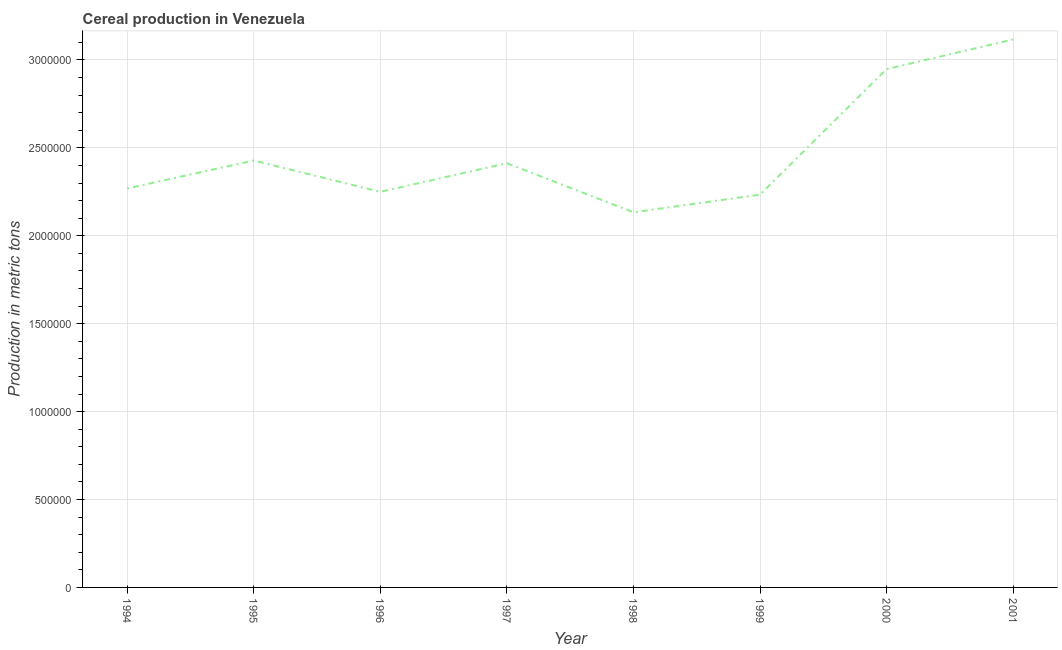What is the cereal production in 1998?
Provide a short and direct response. 2.13e+06. Across all years, what is the maximum cereal production?
Your response must be concise. 3.12e+06. Across all years, what is the minimum cereal production?
Provide a succinct answer. 2.13e+06. In which year was the cereal production maximum?
Offer a very short reply. 2001. What is the sum of the cereal production?
Your answer should be very brief. 1.98e+07. What is the difference between the cereal production in 1999 and 2000?
Provide a succinct answer. -7.14e+05. What is the average cereal production per year?
Your answer should be very brief. 2.47e+06. What is the median cereal production?
Keep it short and to the point. 2.34e+06. In how many years, is the cereal production greater than 800000 metric tons?
Make the answer very short. 8. Do a majority of the years between 1995 and 1996 (inclusive) have cereal production greater than 100000 metric tons?
Your answer should be very brief. Yes. What is the ratio of the cereal production in 1995 to that in 2000?
Provide a succinct answer. 0.82. Is the cereal production in 1995 less than that in 1996?
Keep it short and to the point. No. Is the difference between the cereal production in 1995 and 1998 greater than the difference between any two years?
Offer a very short reply. No. What is the difference between the highest and the second highest cereal production?
Provide a succinct answer. 1.68e+05. Is the sum of the cereal production in 1996 and 2000 greater than the maximum cereal production across all years?
Provide a short and direct response. Yes. What is the difference between the highest and the lowest cereal production?
Offer a terse response. 9.83e+05. In how many years, is the cereal production greater than the average cereal production taken over all years?
Provide a succinct answer. 2. Does the cereal production monotonically increase over the years?
Give a very brief answer. No. How many years are there in the graph?
Ensure brevity in your answer.  8. Are the values on the major ticks of Y-axis written in scientific E-notation?
Give a very brief answer. No. Does the graph contain any zero values?
Your response must be concise. No. Does the graph contain grids?
Offer a very short reply. Yes. What is the title of the graph?
Provide a short and direct response. Cereal production in Venezuela. What is the label or title of the X-axis?
Provide a short and direct response. Year. What is the label or title of the Y-axis?
Your answer should be compact. Production in metric tons. What is the Production in metric tons of 1994?
Your response must be concise. 2.27e+06. What is the Production in metric tons in 1995?
Provide a short and direct response. 2.43e+06. What is the Production in metric tons of 1996?
Provide a short and direct response. 2.25e+06. What is the Production in metric tons in 1997?
Give a very brief answer. 2.41e+06. What is the Production in metric tons in 1998?
Provide a short and direct response. 2.13e+06. What is the Production in metric tons of 1999?
Offer a very short reply. 2.23e+06. What is the Production in metric tons in 2000?
Keep it short and to the point. 2.95e+06. What is the Production in metric tons in 2001?
Make the answer very short. 3.12e+06. What is the difference between the Production in metric tons in 1994 and 1995?
Make the answer very short. -1.59e+05. What is the difference between the Production in metric tons in 1994 and 1996?
Give a very brief answer. 1.90e+04. What is the difference between the Production in metric tons in 1994 and 1997?
Make the answer very short. -1.44e+05. What is the difference between the Production in metric tons in 1994 and 1998?
Provide a short and direct response. 1.35e+05. What is the difference between the Production in metric tons in 1994 and 1999?
Make the answer very short. 3.50e+04. What is the difference between the Production in metric tons in 1994 and 2000?
Provide a short and direct response. -6.79e+05. What is the difference between the Production in metric tons in 1994 and 2001?
Provide a succinct answer. -8.48e+05. What is the difference between the Production in metric tons in 1995 and 1996?
Ensure brevity in your answer.  1.78e+05. What is the difference between the Production in metric tons in 1995 and 1997?
Your answer should be very brief. 1.52e+04. What is the difference between the Production in metric tons in 1995 and 1998?
Your answer should be compact. 2.95e+05. What is the difference between the Production in metric tons in 1995 and 1999?
Keep it short and to the point. 1.94e+05. What is the difference between the Production in metric tons in 1995 and 2000?
Give a very brief answer. -5.20e+05. What is the difference between the Production in metric tons in 1995 and 2001?
Offer a very short reply. -6.89e+05. What is the difference between the Production in metric tons in 1996 and 1997?
Provide a short and direct response. -1.63e+05. What is the difference between the Production in metric tons in 1996 and 1998?
Ensure brevity in your answer.  1.16e+05. What is the difference between the Production in metric tons in 1996 and 1999?
Offer a very short reply. 1.60e+04. What is the difference between the Production in metric tons in 1996 and 2000?
Your answer should be very brief. -6.98e+05. What is the difference between the Production in metric tons in 1996 and 2001?
Give a very brief answer. -8.67e+05. What is the difference between the Production in metric tons in 1997 and 1998?
Provide a short and direct response. 2.79e+05. What is the difference between the Production in metric tons in 1997 and 1999?
Your answer should be compact. 1.79e+05. What is the difference between the Production in metric tons in 1997 and 2000?
Provide a short and direct response. -5.35e+05. What is the difference between the Production in metric tons in 1997 and 2001?
Offer a terse response. -7.04e+05. What is the difference between the Production in metric tons in 1998 and 1999?
Give a very brief answer. -1.00e+05. What is the difference between the Production in metric tons in 1998 and 2000?
Make the answer very short. -8.15e+05. What is the difference between the Production in metric tons in 1998 and 2001?
Make the answer very short. -9.83e+05. What is the difference between the Production in metric tons in 1999 and 2000?
Offer a very short reply. -7.14e+05. What is the difference between the Production in metric tons in 1999 and 2001?
Offer a terse response. -8.83e+05. What is the difference between the Production in metric tons in 2000 and 2001?
Your answer should be very brief. -1.68e+05. What is the ratio of the Production in metric tons in 1994 to that in 1995?
Make the answer very short. 0.93. What is the ratio of the Production in metric tons in 1994 to that in 1997?
Keep it short and to the point. 0.94. What is the ratio of the Production in metric tons in 1994 to that in 1998?
Give a very brief answer. 1.06. What is the ratio of the Production in metric tons in 1994 to that in 2000?
Provide a succinct answer. 0.77. What is the ratio of the Production in metric tons in 1994 to that in 2001?
Your answer should be very brief. 0.73. What is the ratio of the Production in metric tons in 1995 to that in 1996?
Offer a terse response. 1.08. What is the ratio of the Production in metric tons in 1995 to that in 1998?
Your answer should be very brief. 1.14. What is the ratio of the Production in metric tons in 1995 to that in 1999?
Give a very brief answer. 1.09. What is the ratio of the Production in metric tons in 1995 to that in 2000?
Give a very brief answer. 0.82. What is the ratio of the Production in metric tons in 1995 to that in 2001?
Make the answer very short. 0.78. What is the ratio of the Production in metric tons in 1996 to that in 1997?
Make the answer very short. 0.93. What is the ratio of the Production in metric tons in 1996 to that in 1998?
Give a very brief answer. 1.05. What is the ratio of the Production in metric tons in 1996 to that in 1999?
Keep it short and to the point. 1.01. What is the ratio of the Production in metric tons in 1996 to that in 2000?
Your answer should be compact. 0.76. What is the ratio of the Production in metric tons in 1996 to that in 2001?
Your answer should be very brief. 0.72. What is the ratio of the Production in metric tons in 1997 to that in 1998?
Ensure brevity in your answer.  1.13. What is the ratio of the Production in metric tons in 1997 to that in 2000?
Provide a succinct answer. 0.82. What is the ratio of the Production in metric tons in 1997 to that in 2001?
Your answer should be very brief. 0.77. What is the ratio of the Production in metric tons in 1998 to that in 1999?
Ensure brevity in your answer.  0.95. What is the ratio of the Production in metric tons in 1998 to that in 2000?
Make the answer very short. 0.72. What is the ratio of the Production in metric tons in 1998 to that in 2001?
Offer a terse response. 0.69. What is the ratio of the Production in metric tons in 1999 to that in 2000?
Provide a short and direct response. 0.76. What is the ratio of the Production in metric tons in 1999 to that in 2001?
Your answer should be compact. 0.72. What is the ratio of the Production in metric tons in 2000 to that in 2001?
Keep it short and to the point. 0.95. 